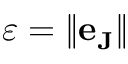<formula> <loc_0><loc_0><loc_500><loc_500>\varepsilon = \| e _ { J } \|</formula> 